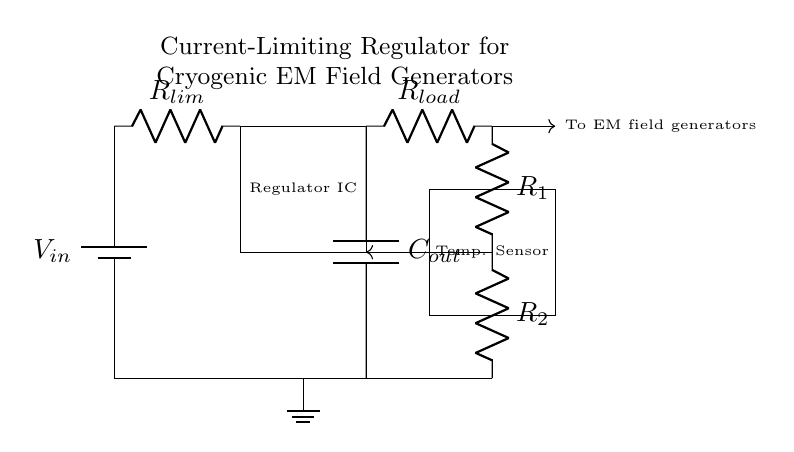What is the type of the main power supply in this circuit? The main power supply is labeled as a battery, which is indicated by the symbol commonly used for batteries.
Answer: Battery What does the output capacitor do in the circuit? The output capacitor, labeled as C out, helps stabilize the output voltage and smooths out any fluctuations that might occur during operation.
Answer: Stabilizes output What component limits the current in this circuit? The resistor labeled R lim is responsible for limiting the current flowing into the regulator and protects the other components.
Answer: R lim How many resistors are used in the feedback network? There are two resistors labeled R1 and R2 that are part of the feedback network, influencing the performance of the regulator.
Answer: Two Why is a temperature sensor included in this circuit? The temperature sensor monitors the temperature within the cryogenic chamber, allowing for adjustments to maintain the optimal operating conditions for the electromagnetic field generators.
Answer: To monitor temperature What is the load represented in this circuit? The load is represented by the resistor labeled R load, which receives the regulated output current for the electromagnetic field generators.
Answer: R load What is the purpose of the current-limiting regulator in this circuit? The current-limiting regulator ensures that the electromagnetic field generators operate within safe current limits while maintaining precise control over the output.
Answer: Current regulation 